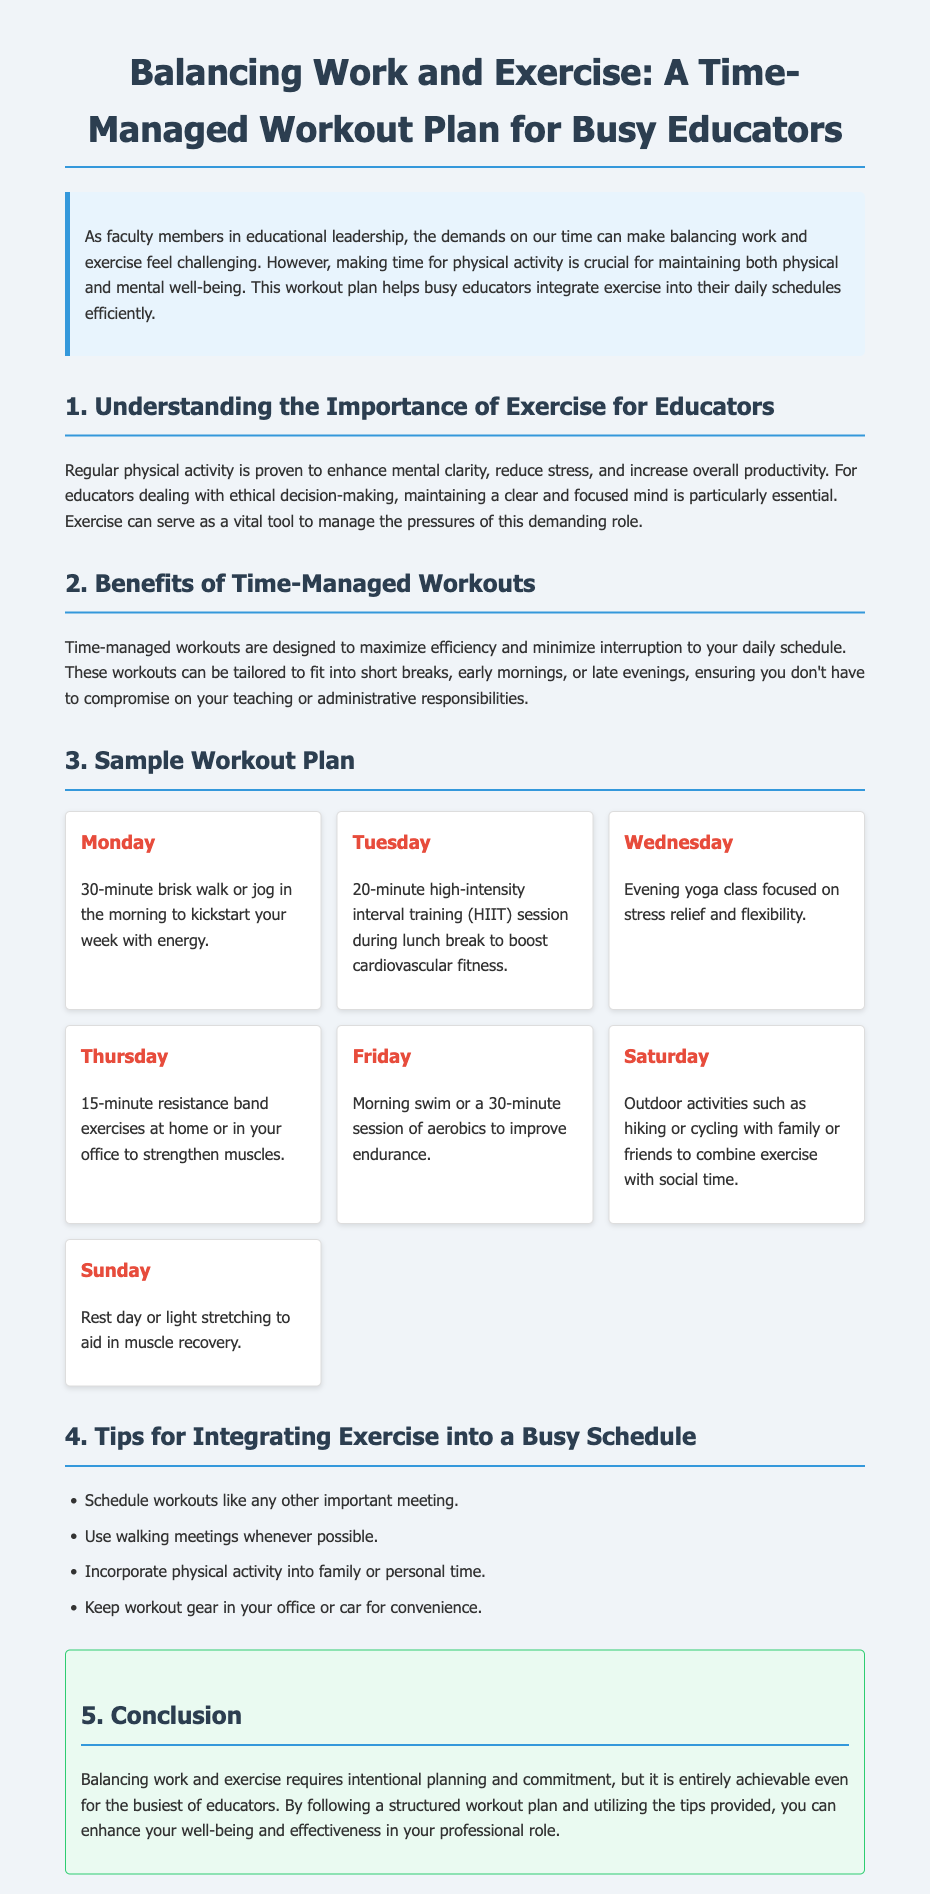What is the title of the document? The title of the document is stated in the header and is "Balancing Work and Exercise: A Time-Managed Workout Plan for Busy Educators."
Answer: Balancing Work and Exercise: A Time-Managed Workout Plan for Busy Educators What is the activity suggested for Monday? The activity for Monday is described in the sample workout plan as a "30-minute brisk walk or jog in the morning."
Answer: 30-minute brisk walk or jog What is one benefit of time-managed workouts? One benefit of time-managed workouts is mentioned in the document as maximizing efficiency and minimizing interruption to your daily schedule.
Answer: Maximize efficiency What type of exercise is recommended for Wednesday? The workout plan specifies that Wednesday includes "Evening yoga class focused on stress relief and flexibility."
Answer: Evening yoga class How long is the HIIT session suggested for Tuesday? The document states that the HIIT session on Tuesday lasts for "20 minutes."
Answer: 20 minutes What day is designated as a rest day? The workout plan indicates that Sunday is the designated rest day.
Answer: Sunday What is one tip provided for integrating exercise? The document lists several tips, one of which is "Schedule workouts like any other important meeting."
Answer: Schedule workouts What color is the introduction section? The introduction section has a background color described as "light blue."
Answer: Light blue How many outline sections does the document have? The document includes five numbered sections in the main content, which represents the workout plan for busy educators.
Answer: Five 